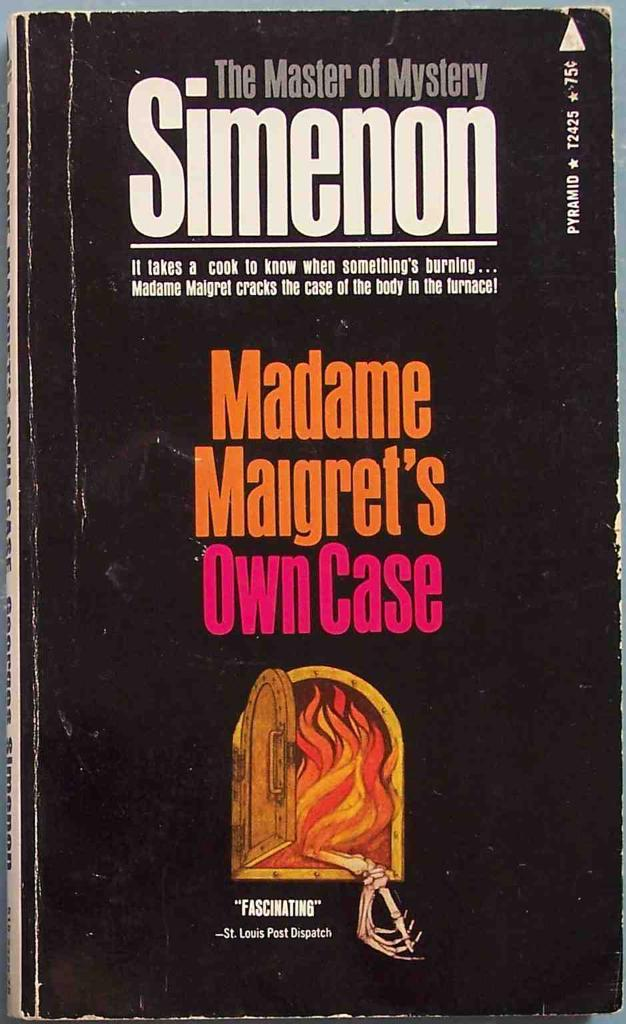<image>
Provide a brief description of the given image. A paperback book called Madame Maigret's Own Case 